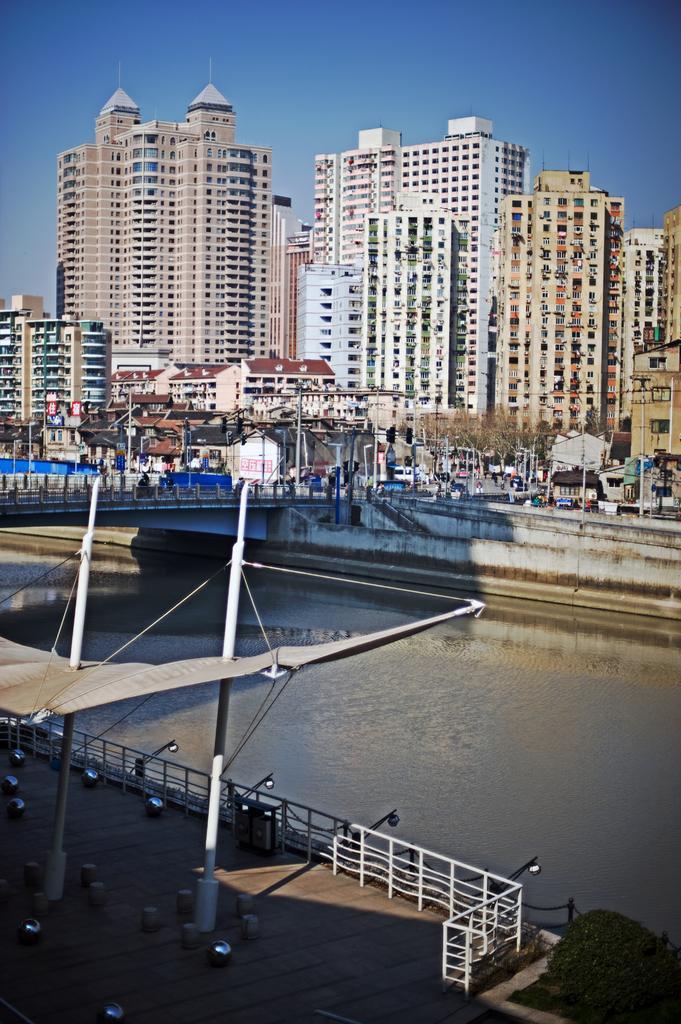Please provide a concise description of this image. In this picture we can see few poles, lights, fence and water, in the background we can find few buildings and trees. 